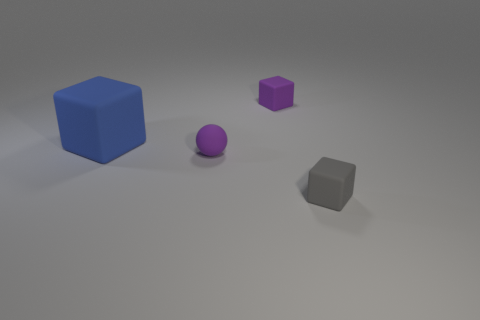What material is the gray thing that is the same size as the purple rubber ball? rubber 